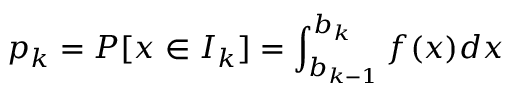Convert formula to latex. <formula><loc_0><loc_0><loc_500><loc_500>p _ { k } = P [ x \in I _ { k } ] = \int _ { b _ { k - 1 } } ^ { b _ { k } } f ( x ) d x</formula> 